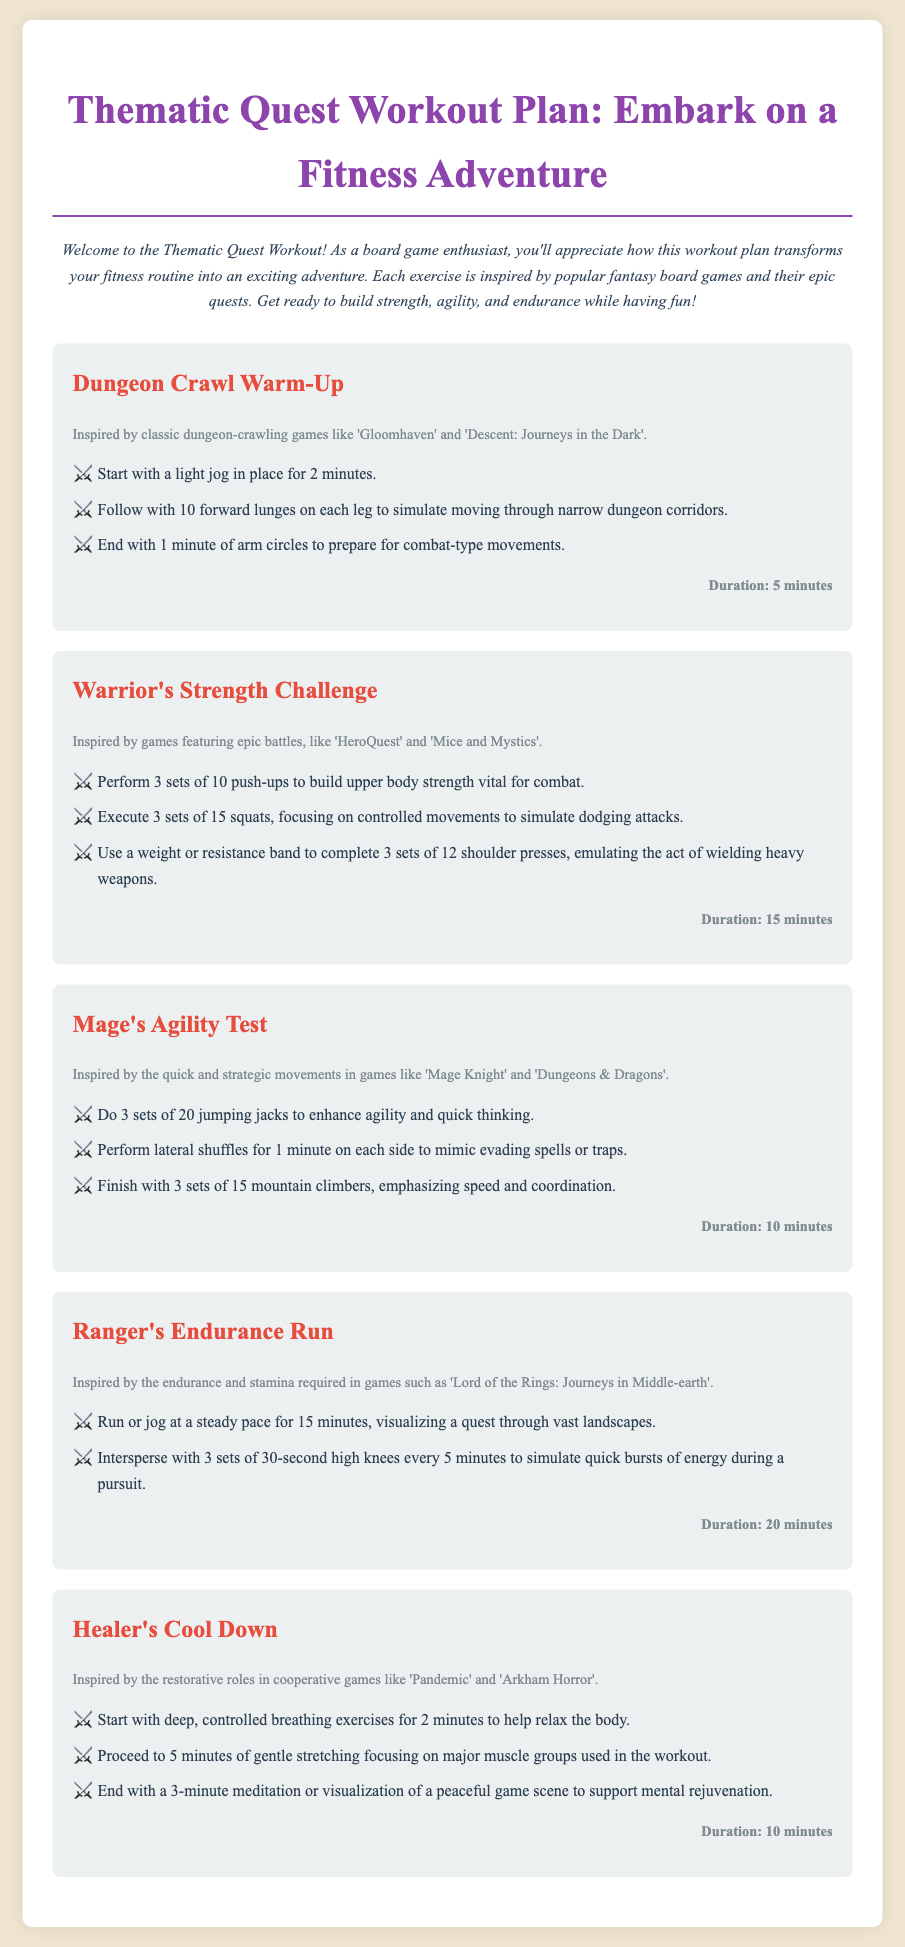What is the title of the workout plan? The title is found at the top of the document, emphasizing the theme of the workout.
Answer: Thematic Quest Workout Plan: Embark on a Fitness Adventure How long is the Dungeon Crawl Warm-Up? The duration is specified within the section detailing the exercise, indicating its length.
Answer: 5 minutes What inspired the Warrior's Strength Challenge? Each exercise includes a phrase that describes its inspiration, showcasing the thematic elements.
Answer: HeroQuest and Mice and Mystics How many jumping jacks are suggested in the Mage's Agility Test? The specific number of jumping jacks is mentioned in the list of steps for this exercise.
Answer: 20 What type of exercises are included in the Healer's Cool Down? The types of exercises are listed clearly in the steps for this section, aiming to help relax the body.
Answer: Breathing exercises, stretching, meditation What is the total duration of the Ranger's Endurance Run including the high knees? To find the total duration, combine the main running time with the intervals suggested.
Answer: 20 minutes Which exercise has a focus on agility and quick thinking? The exercises in the workout plan are named, each with a distinct focus associated with a theme.
Answer: Mage's Agility Test How many sets of push-ups are recommended in the Warrior's Strength Challenge? The number of sets for push-ups is explicitly mentioned in the list of steps for this exercise.
Answer: 3 sets 